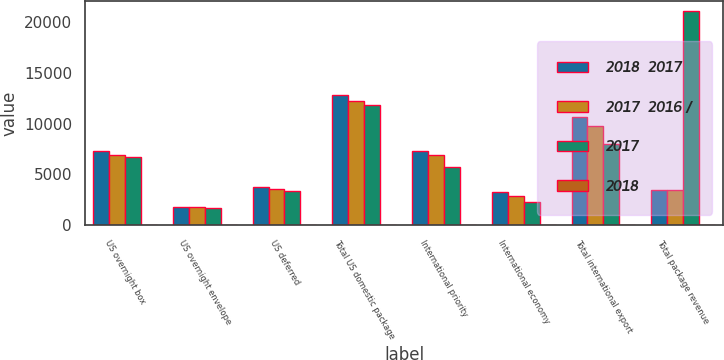Convert chart. <chart><loc_0><loc_0><loc_500><loc_500><stacked_bar_chart><ecel><fcel>US overnight box<fcel>US overnight envelope<fcel>US deferred<fcel>Total US domestic package<fcel>International priority<fcel>International economy<fcel>Total international export<fcel>Total package revenue<nl><fcel>2018  2017<fcel>7273<fcel>1788<fcel>3738<fcel>12799<fcel>7356<fcel>3255<fcel>10611<fcel>3452.5<nl><fcel>2017  2016 /<fcel>6955<fcel>1750<fcel>3526<fcel>12231<fcel>6940<fcel>2876<fcel>9816<fcel>3452.5<nl><fcel>2017<fcel>6763<fcel>1662<fcel>3379<fcel>11804<fcel>5697<fcel>2282<fcel>7979<fcel>21068<nl><fcel>2018<fcel>5<fcel>2<fcel>6<fcel>5<fcel>6<fcel>13<fcel>8<fcel>7<nl></chart> 